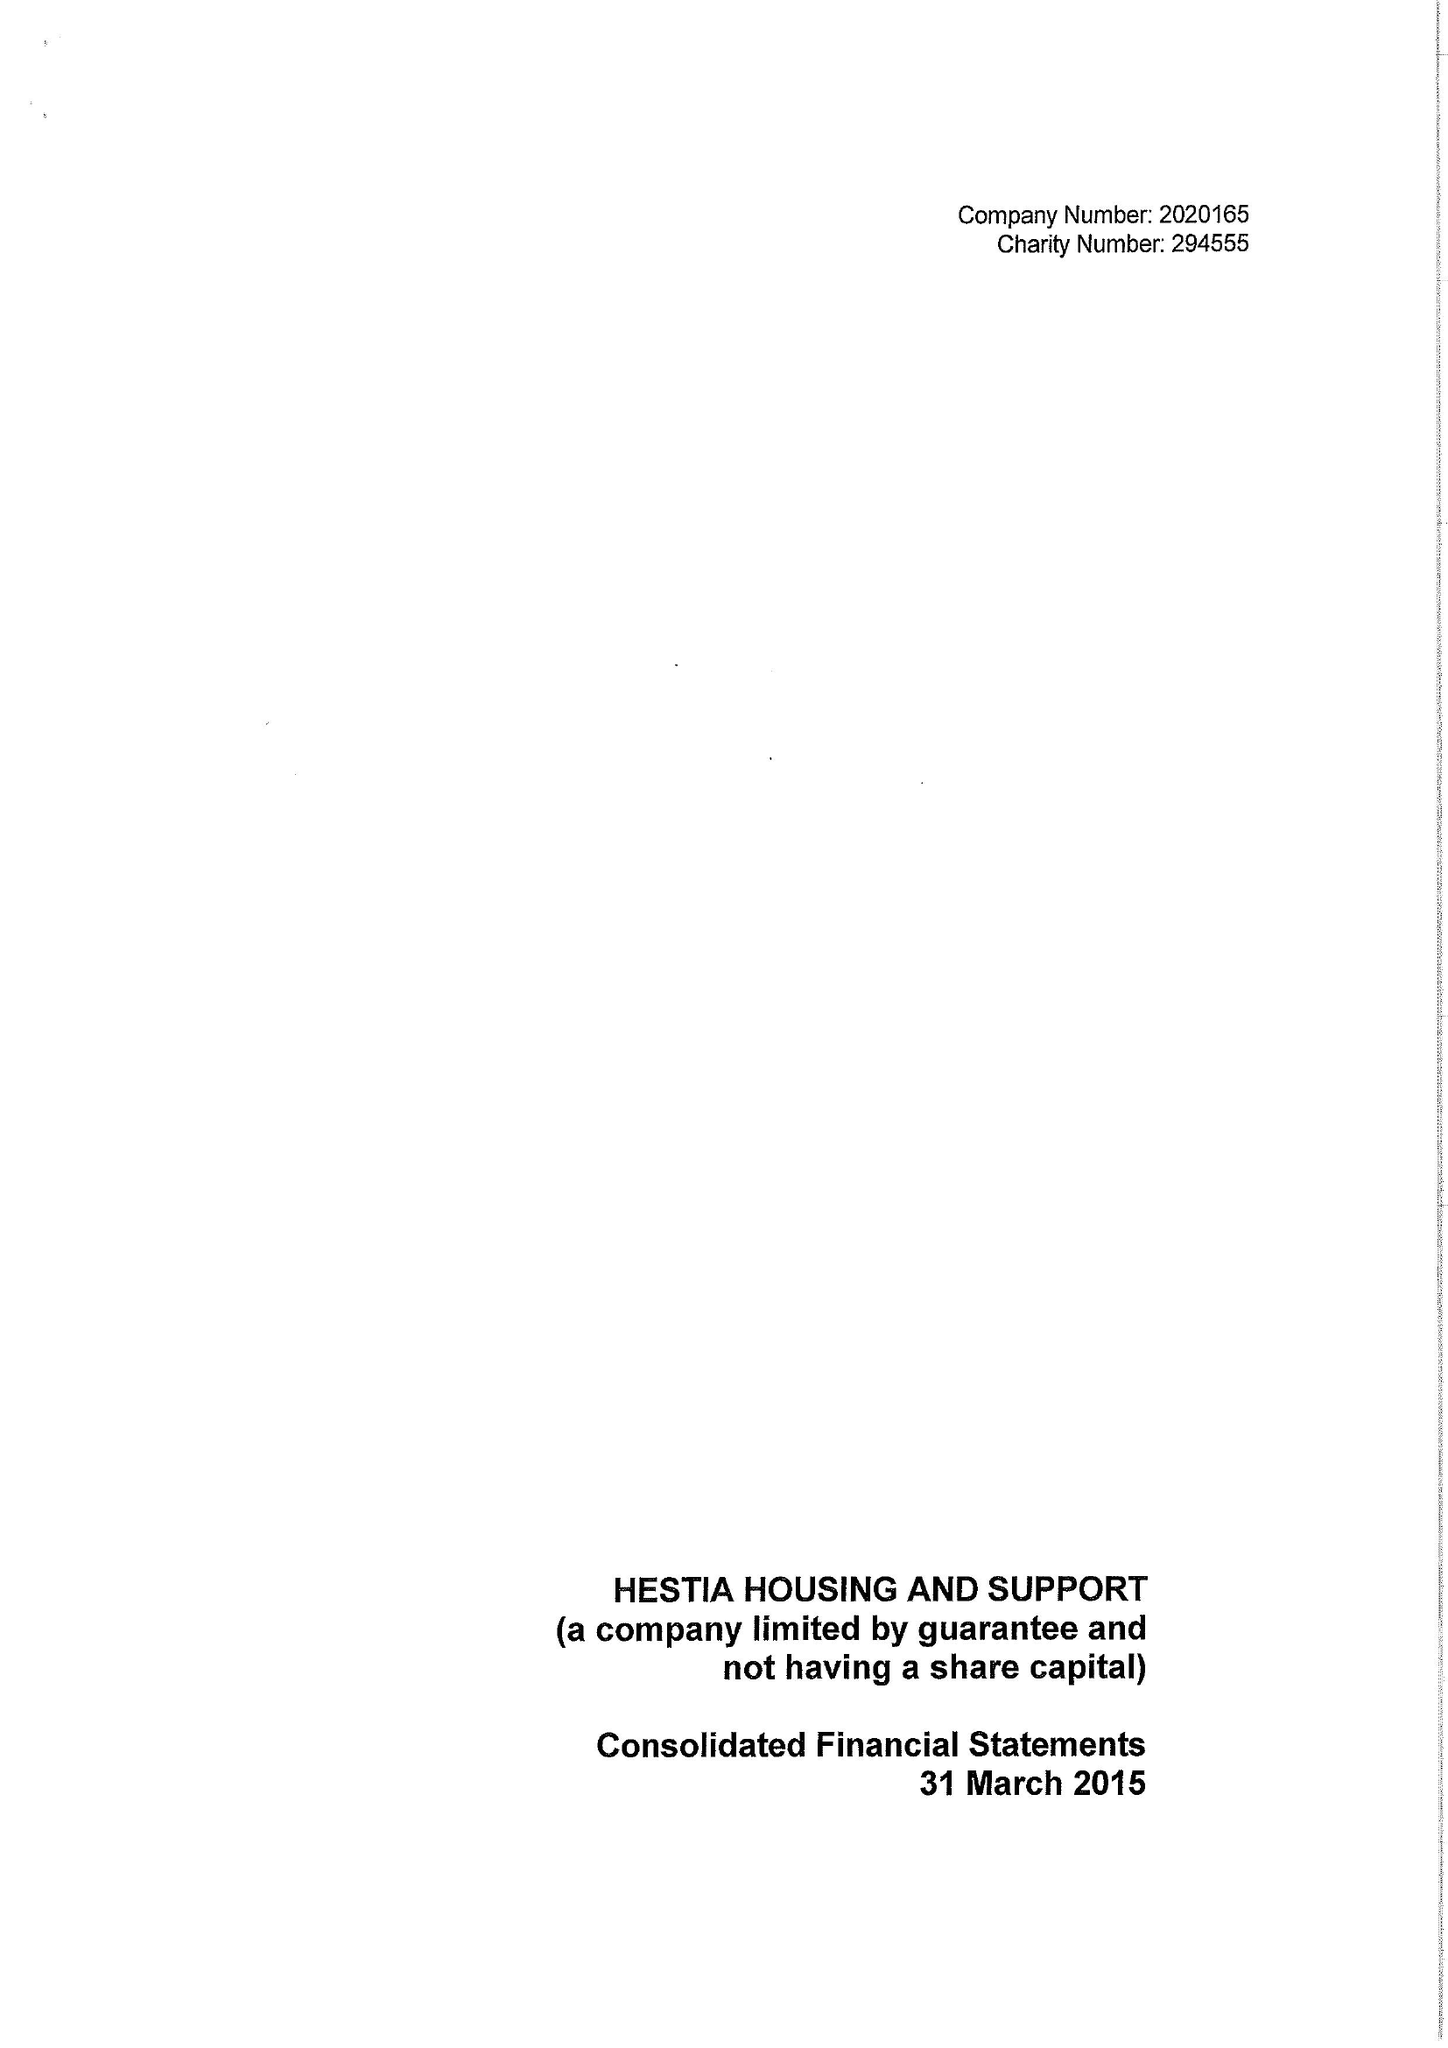What is the value for the report_date?
Answer the question using a single word or phrase. 2015-03-31 